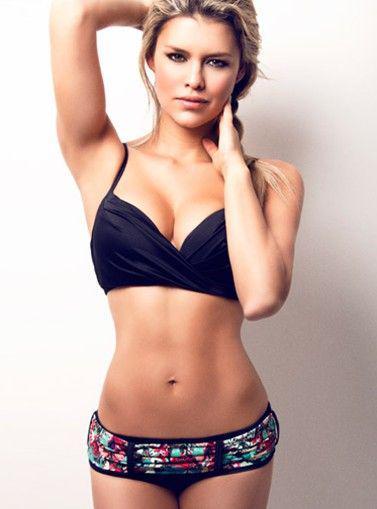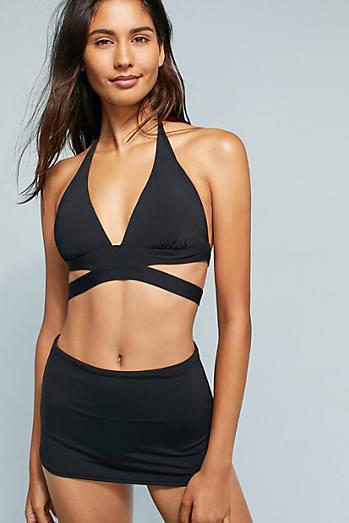The first image is the image on the left, the second image is the image on the right. Examine the images to the left and right. Is the description "Both bottoms are solid black." accurate? Answer yes or no. No. The first image is the image on the left, the second image is the image on the right. Analyze the images presented: Is the assertion "Each model is wearing a black bikini top and bottom." valid? Answer yes or no. No. 